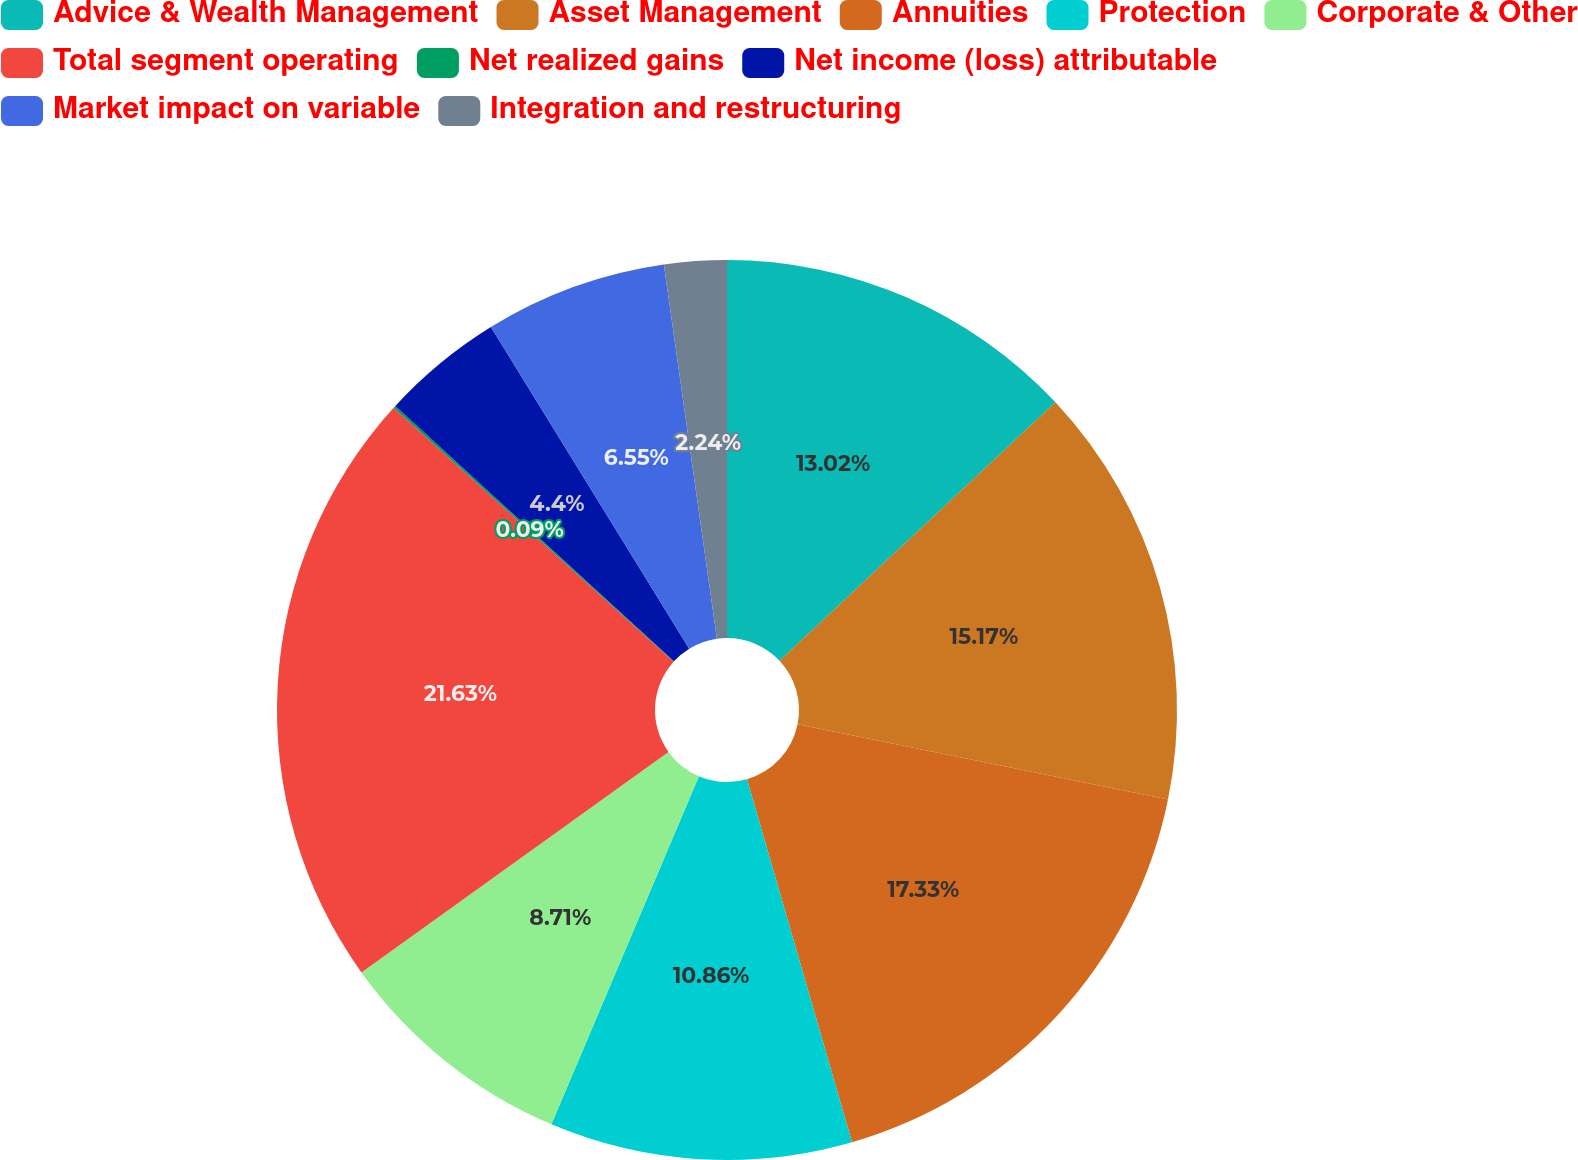Convert chart. <chart><loc_0><loc_0><loc_500><loc_500><pie_chart><fcel>Advice & Wealth Management<fcel>Asset Management<fcel>Annuities<fcel>Protection<fcel>Corporate & Other<fcel>Total segment operating<fcel>Net realized gains<fcel>Net income (loss) attributable<fcel>Market impact on variable<fcel>Integration and restructuring<nl><fcel>13.02%<fcel>15.17%<fcel>17.33%<fcel>10.86%<fcel>8.71%<fcel>21.63%<fcel>0.09%<fcel>4.4%<fcel>6.55%<fcel>2.24%<nl></chart> 